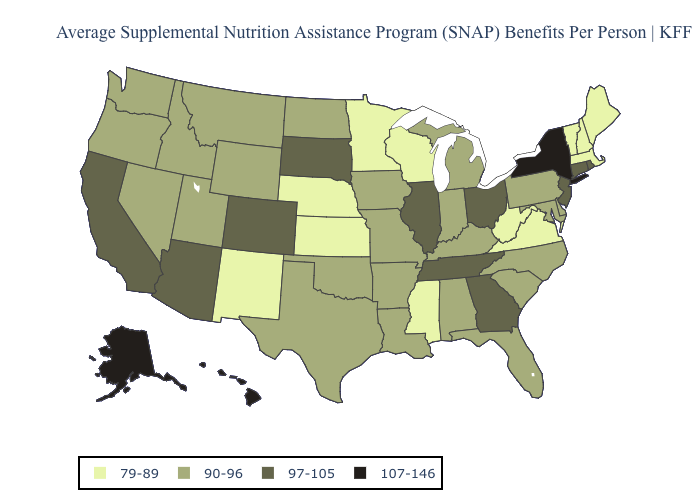What is the lowest value in states that border Florida?
Short answer required. 90-96. Which states have the lowest value in the USA?
Concise answer only. Kansas, Maine, Massachusetts, Minnesota, Mississippi, Nebraska, New Hampshire, New Mexico, Vermont, Virginia, West Virginia, Wisconsin. Which states have the lowest value in the USA?
Short answer required. Kansas, Maine, Massachusetts, Minnesota, Mississippi, Nebraska, New Hampshire, New Mexico, Vermont, Virginia, West Virginia, Wisconsin. What is the lowest value in states that border Washington?
Give a very brief answer. 90-96. Name the states that have a value in the range 107-146?
Be succinct. Alaska, Hawaii, New York. Is the legend a continuous bar?
Write a very short answer. No. Among the states that border Wyoming , which have the highest value?
Be succinct. Colorado, South Dakota. Does Washington have a lower value than South Carolina?
Short answer required. No. Name the states that have a value in the range 97-105?
Write a very short answer. Arizona, California, Colorado, Connecticut, Georgia, Illinois, New Jersey, Ohio, Rhode Island, South Dakota, Tennessee. What is the value of Maine?
Answer briefly. 79-89. Among the states that border Delaware , which have the lowest value?
Concise answer only. Maryland, Pennsylvania. Name the states that have a value in the range 79-89?
Give a very brief answer. Kansas, Maine, Massachusetts, Minnesota, Mississippi, Nebraska, New Hampshire, New Mexico, Vermont, Virginia, West Virginia, Wisconsin. Does Texas have the lowest value in the South?
Keep it brief. No. Name the states that have a value in the range 97-105?
Keep it brief. Arizona, California, Colorado, Connecticut, Georgia, Illinois, New Jersey, Ohio, Rhode Island, South Dakota, Tennessee. 